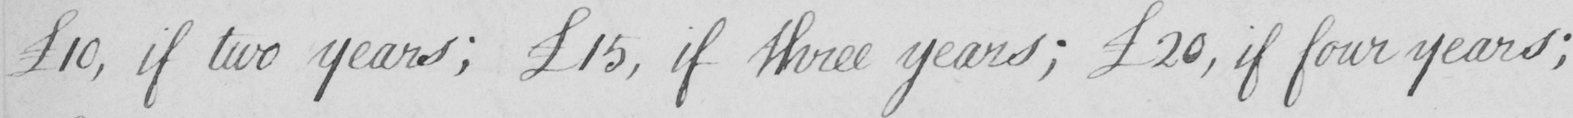What does this handwritten line say? 10 , if two years ; £15 , if three years ; £20 , if four years ; 